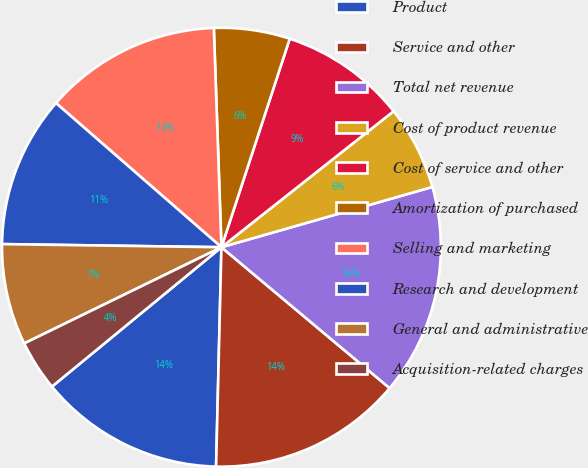Convert chart. <chart><loc_0><loc_0><loc_500><loc_500><pie_chart><fcel>Product<fcel>Service and other<fcel>Total net revenue<fcel>Cost of product revenue<fcel>Cost of service and other<fcel>Amortization of purchased<fcel>Selling and marketing<fcel>Research and development<fcel>General and administrative<fcel>Acquisition-related charges<nl><fcel>13.66%<fcel>14.29%<fcel>15.53%<fcel>6.21%<fcel>9.32%<fcel>5.59%<fcel>13.04%<fcel>11.18%<fcel>7.45%<fcel>3.73%<nl></chart> 